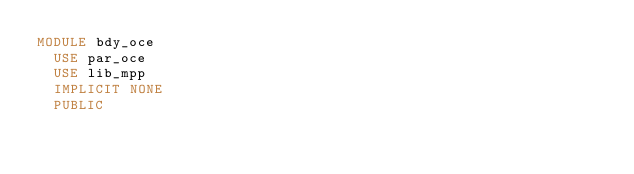<code> <loc_0><loc_0><loc_500><loc_500><_FORTRAN_>MODULE bdy_oce
  USE par_oce
  USE lib_mpp
  IMPLICIT NONE
  PUBLIC</code> 